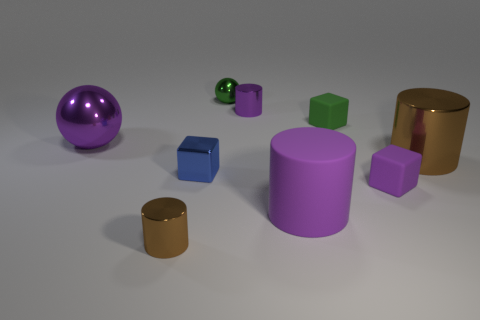Subtract all purple metal cylinders. How many cylinders are left? 3 Subtract 2 cylinders. How many cylinders are left? 2 Subtract all blue cubes. How many brown cylinders are left? 2 Subtract all purple cylinders. How many cylinders are left? 2 Subtract all balls. How many objects are left? 7 Subtract 0 blue balls. How many objects are left? 9 Subtract all red cylinders. Subtract all red balls. How many cylinders are left? 4 Subtract all tiny red blocks. Subtract all big metal things. How many objects are left? 7 Add 1 blue shiny blocks. How many blue shiny blocks are left? 2 Add 7 cyan shiny blocks. How many cyan shiny blocks exist? 7 